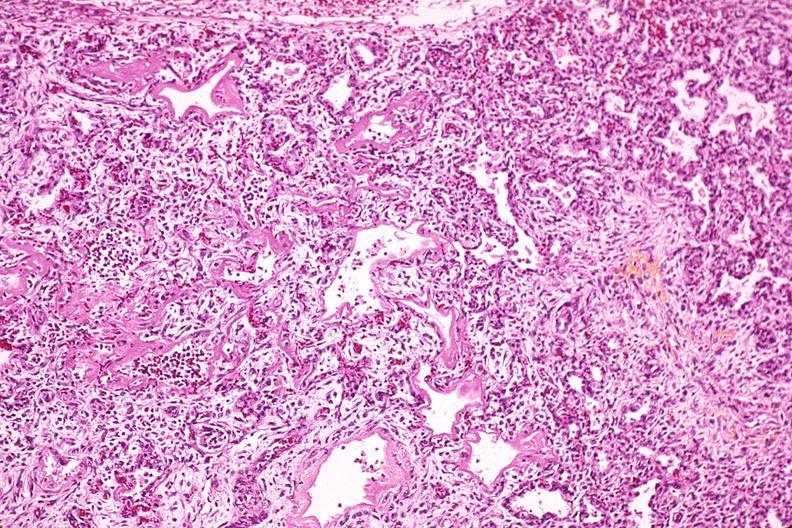does this image show lung, hyaline membrane disease, yellow discoloration due to hyperbilirubinemia?
Answer the question using a single word or phrase. Yes 